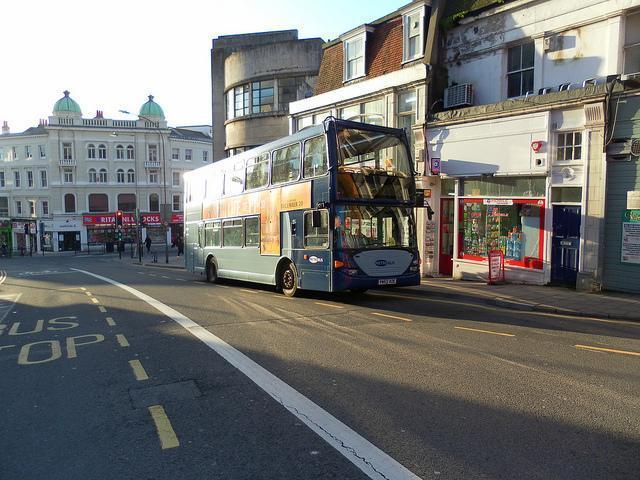How many trains are in the image?
Give a very brief answer. 0. 